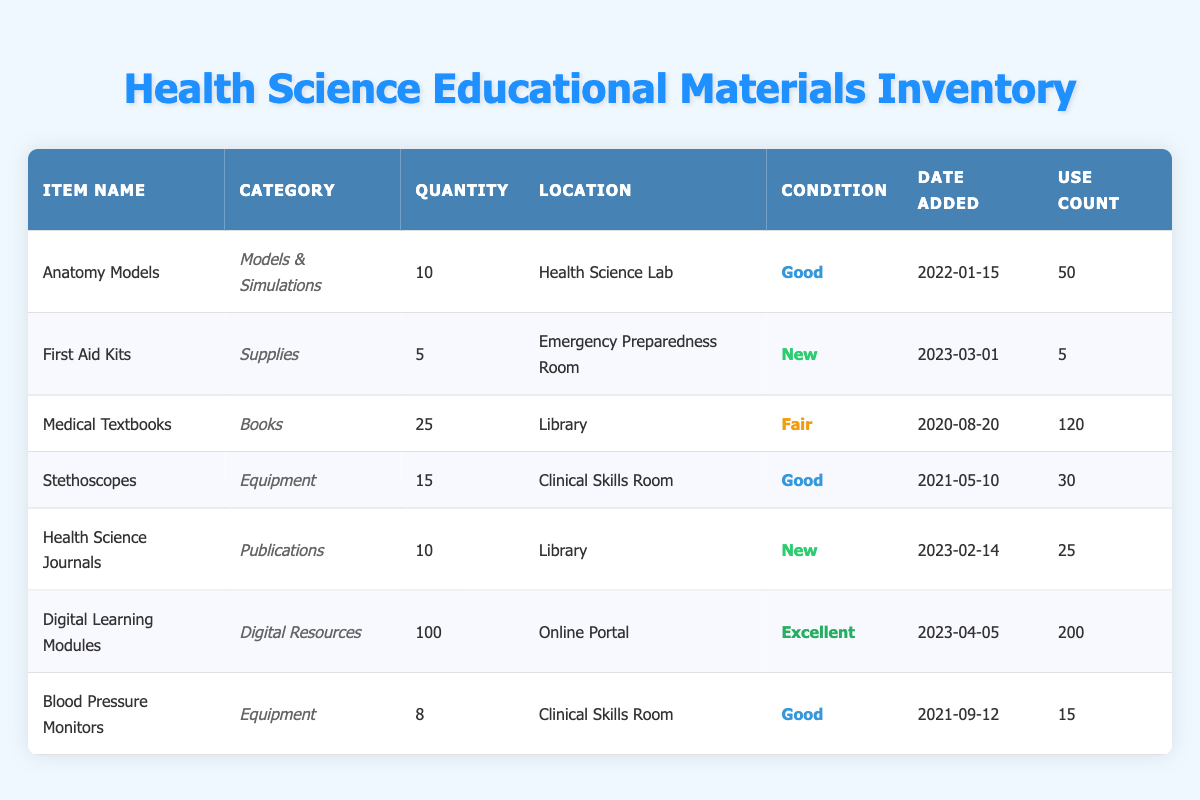What is the total quantity of all items listed in the inventory? We need to add the quantity of each item: 10 (Anatomy Models) + 5 (First Aid Kits) + 25 (Medical Textbooks) + 15 (Stethoscopes) + 10 (Health Science Journals) + 100 (Digital Learning Modules) + 8 (Blood Pressure Monitors) = 173.
Answer: 173 Which item has been used the most based on use count? The use counts for each item are as follows: 50 (Anatomy Models), 5 (First Aid Kits), 120 (Medical Textbooks), 30 (Stethoscopes), 25 (Health Science Journals), 200 (Digital Learning Modules), 15 (Blood Pressure Monitors). The highest use count is 200 for Digital Learning Modules.
Answer: Digital Learning Modules Is there an item in the inventory with "Excellent" condition? By checking the condition of each item, we find that Digital Learning Modules is marked as "Excellent".
Answer: Yes How many items are in "Good" condition, and what are they? The items in "Good" condition are: Anatomy Models (10), Stethoscopes (15), and Blood Pressure Monitors (8). Therefore, there are 3 items total in "Good" condition.
Answer: 3 items: Anatomy Models, Stethoscopes, Blood Pressure Monitors What is the average quantity of items in "New" condition? The items in "New" condition are First Aid Kits (5) and Health Science Journals (10). To find the average: (5 + 10) / 2 = 7.5.
Answer: 7.5 Are there any items located in the Library? Yes, both Medical Textbooks and Health Science Journals are located in the Library.
Answer: Yes Which equipment is located in the Clinical Skills Room and has a quantity of less than 15? The only equipment in the Clinical Skills Room is Blood Pressure Monitors with a quantity of 8.
Answer: Blood Pressure Monitors What is the total use count for all the supplies? First Aid Kits have a use count of 5. No other supplies are listed. So the total use count is simply 5.
Answer: 5 How many items were added to the inventory on or after March 1, 2023? The items added on or after March 1, 2023, are: First Aid Kits (2023-03-01), Health Science Journals (2023-02-14), and Digital Learning Modules (2023-04-05). Counting these gives us 3 items.
Answer: 3 items 